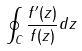Convert formula to latex. <formula><loc_0><loc_0><loc_500><loc_500>\oint _ { C } \frac { f ^ { \prime } ( z ) } { f ( z ) } d z</formula> 